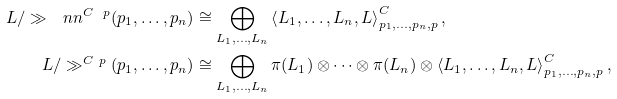<formula> <loc_0><loc_0><loc_500><loc_500>L / \gg _ { \ } n n ^ { C \ p } ( p _ { 1 } , \dots , p _ { n } ) & \cong \bigoplus _ { L _ { 1 } , \dots , L _ { n } } \left < L _ { 1 } , \dots , L _ { n } , L \right > ^ { C } _ { p _ { 1 } , \dots , p _ { n } , p } , \\ L / \gg ^ { C \ p } ( p _ { 1 } , \dots , p _ { n } ) & \cong \bigoplus _ { L _ { 1 } , \dots , L _ { n } } \pi ( L _ { 1 } ) \otimes \dots \otimes \pi ( L _ { n } ) \otimes \left < L _ { 1 } , \dots , L _ { n } , L \right > ^ { C } _ { p _ { 1 } , \dots , p _ { n } , p } ,</formula> 